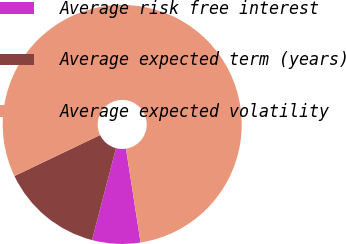<chart> <loc_0><loc_0><loc_500><loc_500><pie_chart><fcel>Average risk free interest<fcel>Average expected term (years)<fcel>Average expected volatility<nl><fcel>6.52%<fcel>13.83%<fcel>79.65%<nl></chart> 